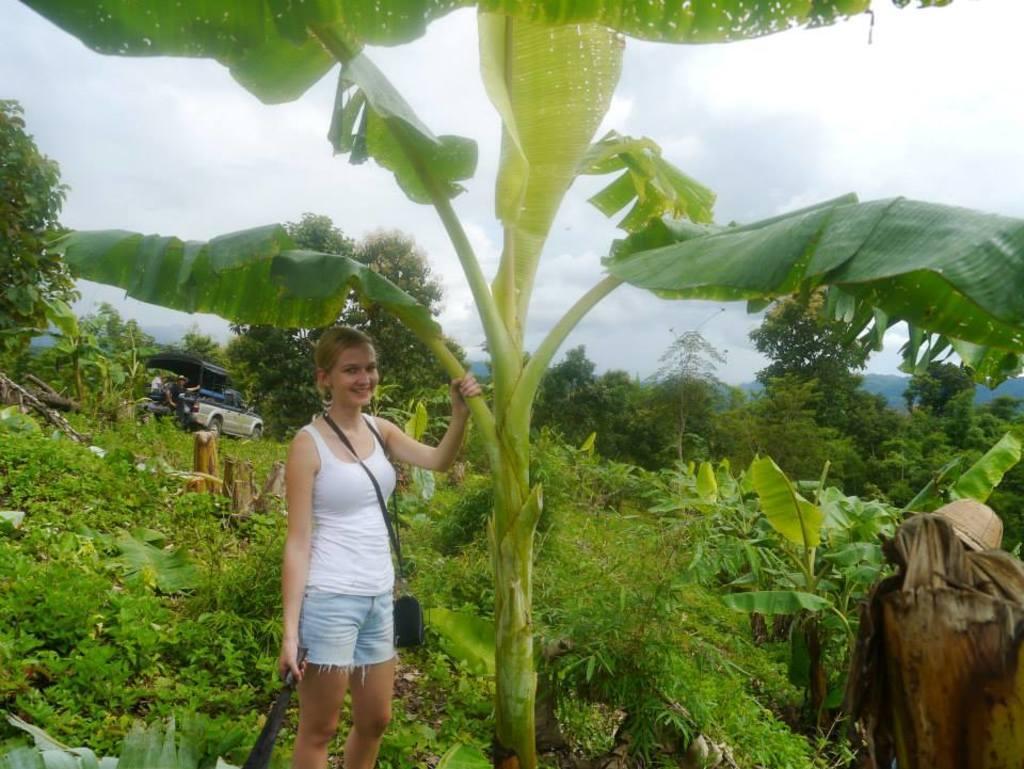Can you describe this image briefly? In this image we can see a woman standing on the ground by holding the tree in one hand and sword in the other hand. In the background we can see plants, creepers, trees, motor vehicle and a person standing in it and sky with clouds. 